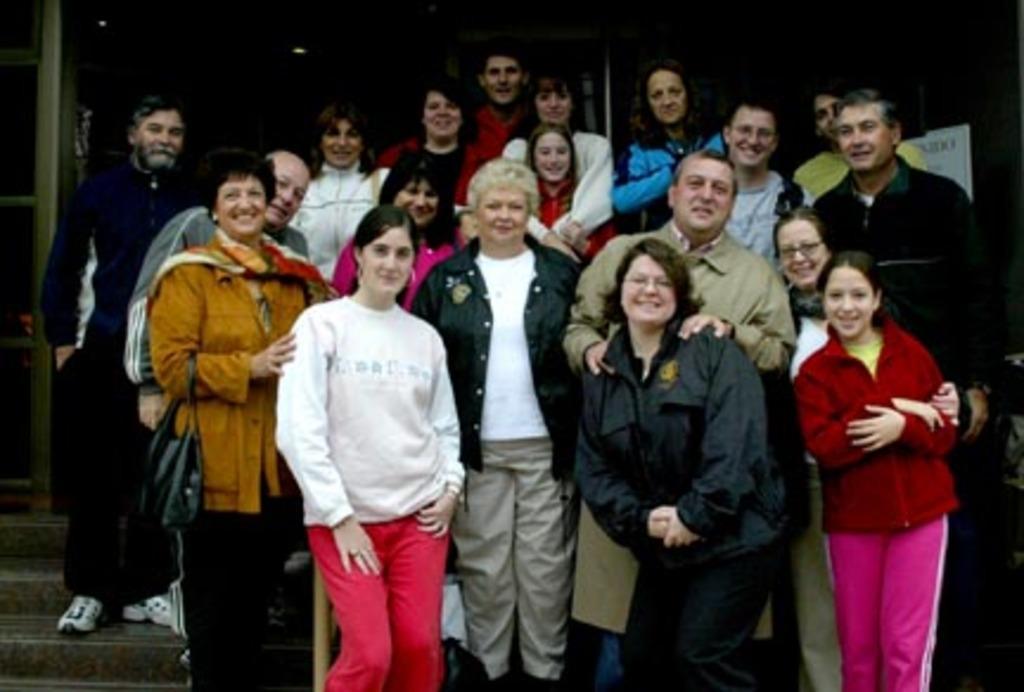How would you summarize this image in a sentence or two? In the image in the center, we can see a group of people are standing and smiling, which we can see on their faces. In the background there is a banner, staircase etc. 